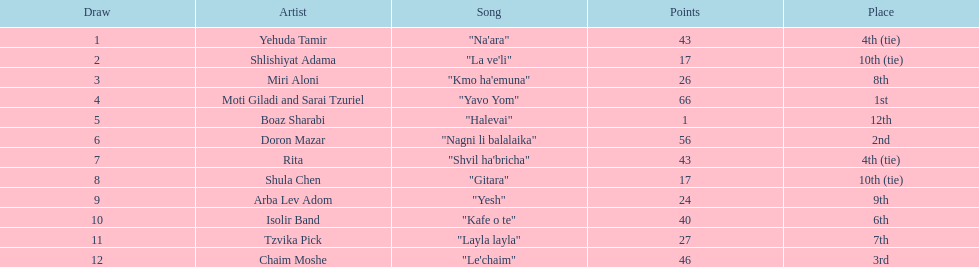What is the overall sum of ties in this contest? 2. 